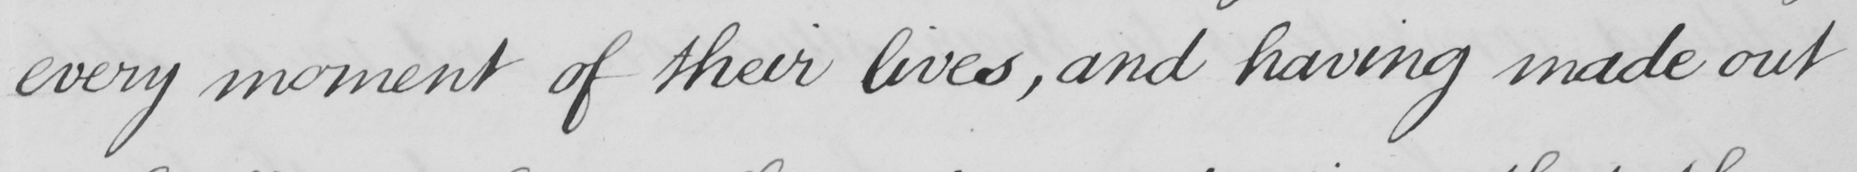What is written in this line of handwriting? every moment of their lives , and having made out 